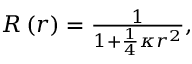<formula> <loc_0><loc_0><loc_500><loc_500>\begin{array} { r } { R \left ( r \right ) = \frac { 1 } { 1 + \frac { 1 } { 4 } \kappa r ^ { 2 } } , } \end{array}</formula> 